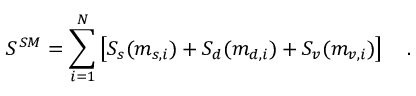Convert formula to latex. <formula><loc_0><loc_0><loc_500><loc_500>S ^ { S M } = \sum _ { i = 1 } ^ { N } \left [ S _ { s } ( m _ { s , i } ) + S _ { d } ( m _ { d , i } ) + S _ { v } ( m _ { v , i } ) \right ] .</formula> 